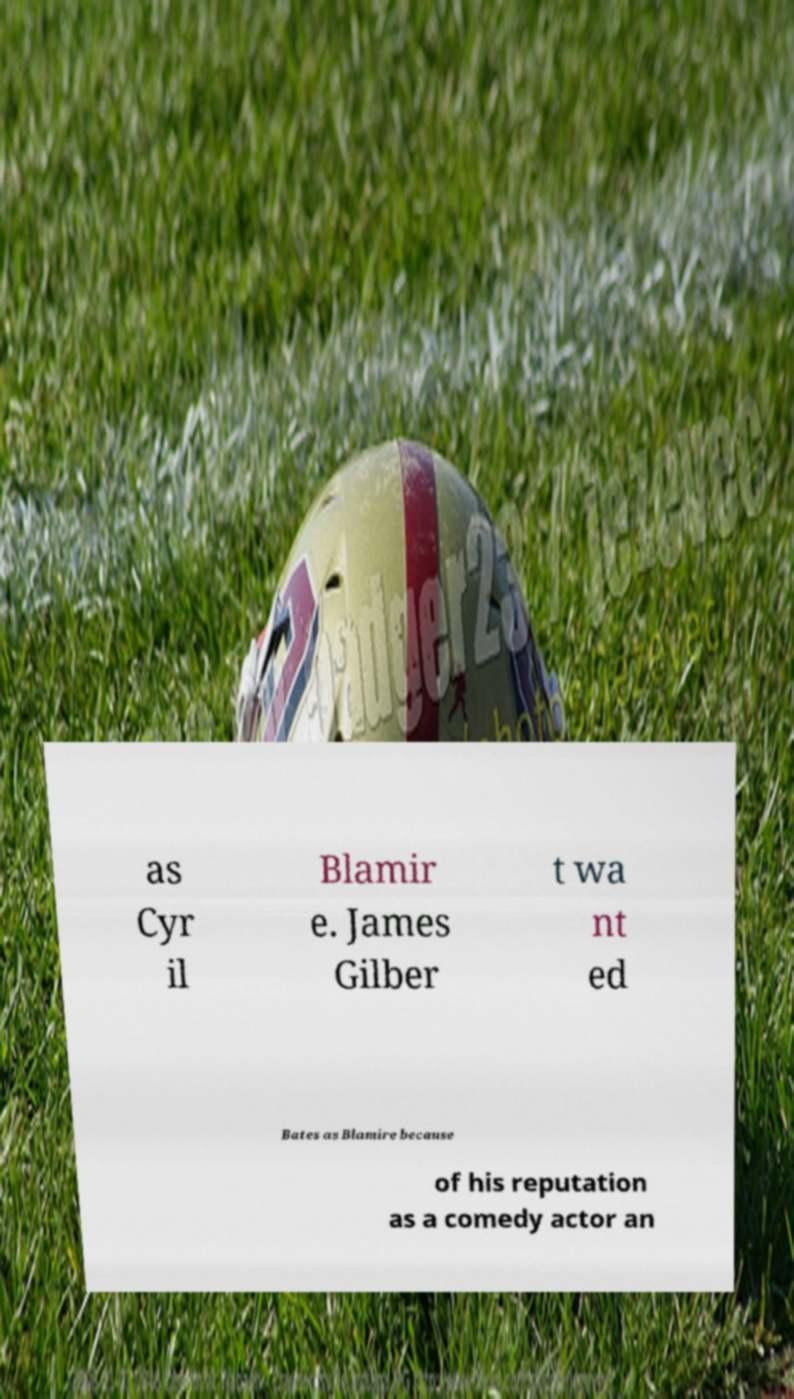Could you assist in decoding the text presented in this image and type it out clearly? as Cyr il Blamir e. James Gilber t wa nt ed Bates as Blamire because of his reputation as a comedy actor an 